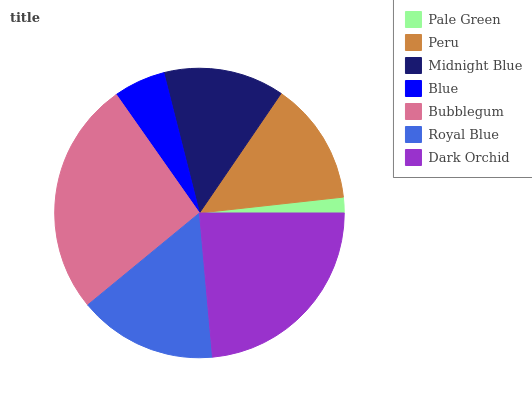Is Pale Green the minimum?
Answer yes or no. Yes. Is Bubblegum the maximum?
Answer yes or no. Yes. Is Peru the minimum?
Answer yes or no. No. Is Peru the maximum?
Answer yes or no. No. Is Peru greater than Pale Green?
Answer yes or no. Yes. Is Pale Green less than Peru?
Answer yes or no. Yes. Is Pale Green greater than Peru?
Answer yes or no. No. Is Peru less than Pale Green?
Answer yes or no. No. Is Peru the high median?
Answer yes or no. Yes. Is Peru the low median?
Answer yes or no. Yes. Is Royal Blue the high median?
Answer yes or no. No. Is Bubblegum the low median?
Answer yes or no. No. 